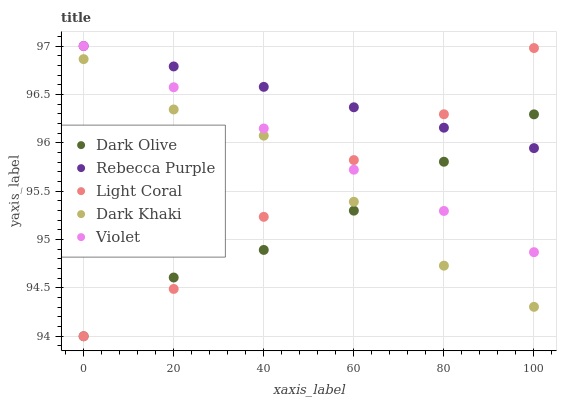Does Dark Olive have the minimum area under the curve?
Answer yes or no. Yes. Does Rebecca Purple have the maximum area under the curve?
Answer yes or no. Yes. Does Dark Khaki have the minimum area under the curve?
Answer yes or no. No. Does Dark Khaki have the maximum area under the curve?
Answer yes or no. No. Is Rebecca Purple the smoothest?
Answer yes or no. Yes. Is Dark Khaki the roughest?
Answer yes or no. Yes. Is Dark Olive the smoothest?
Answer yes or no. No. Is Dark Olive the roughest?
Answer yes or no. No. Does Light Coral have the lowest value?
Answer yes or no. Yes. Does Dark Khaki have the lowest value?
Answer yes or no. No. Does Violet have the highest value?
Answer yes or no. Yes. Does Dark Khaki have the highest value?
Answer yes or no. No. Is Dark Khaki less than Rebecca Purple?
Answer yes or no. Yes. Is Rebecca Purple greater than Dark Khaki?
Answer yes or no. Yes. Does Violet intersect Dark Olive?
Answer yes or no. Yes. Is Violet less than Dark Olive?
Answer yes or no. No. Is Violet greater than Dark Olive?
Answer yes or no. No. Does Dark Khaki intersect Rebecca Purple?
Answer yes or no. No. 